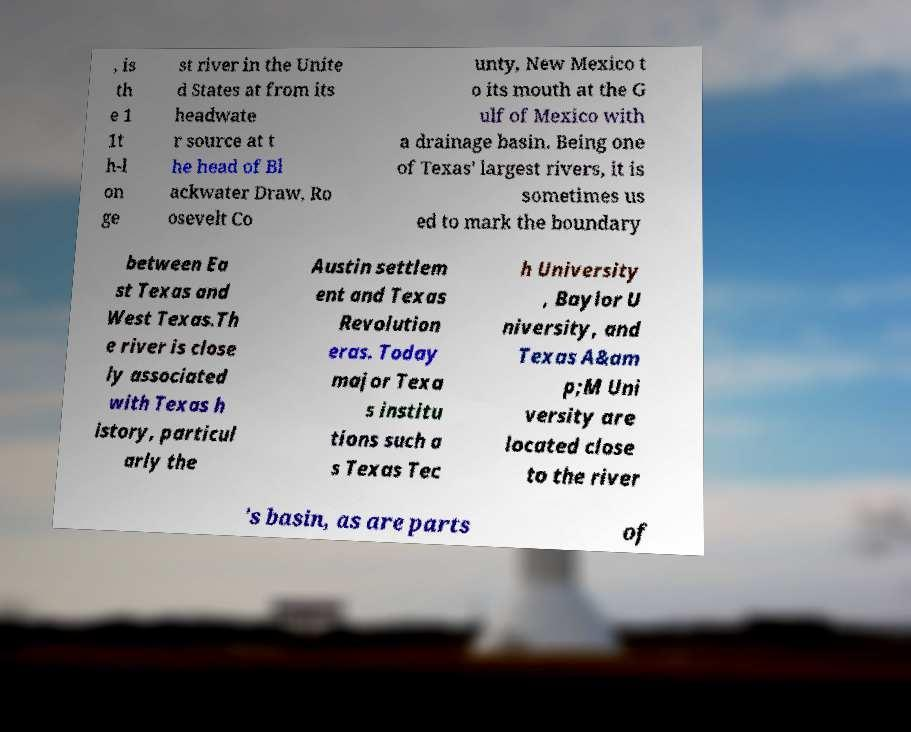There's text embedded in this image that I need extracted. Can you transcribe it verbatim? , is th e 1 1t h-l on ge st river in the Unite d States at from its headwate r source at t he head of Bl ackwater Draw, Ro osevelt Co unty, New Mexico t o its mouth at the G ulf of Mexico with a drainage basin. Being one of Texas' largest rivers, it is sometimes us ed to mark the boundary between Ea st Texas and West Texas.Th e river is close ly associated with Texas h istory, particul arly the Austin settlem ent and Texas Revolution eras. Today major Texa s institu tions such a s Texas Tec h University , Baylor U niversity, and Texas A&am p;M Uni versity are located close to the river 's basin, as are parts of 